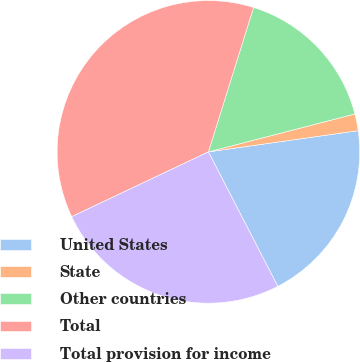Convert chart. <chart><loc_0><loc_0><loc_500><loc_500><pie_chart><fcel>United States<fcel>State<fcel>Other countries<fcel>Total<fcel>Total provision for income<nl><fcel>19.66%<fcel>1.79%<fcel>16.15%<fcel>36.87%<fcel>25.54%<nl></chart> 